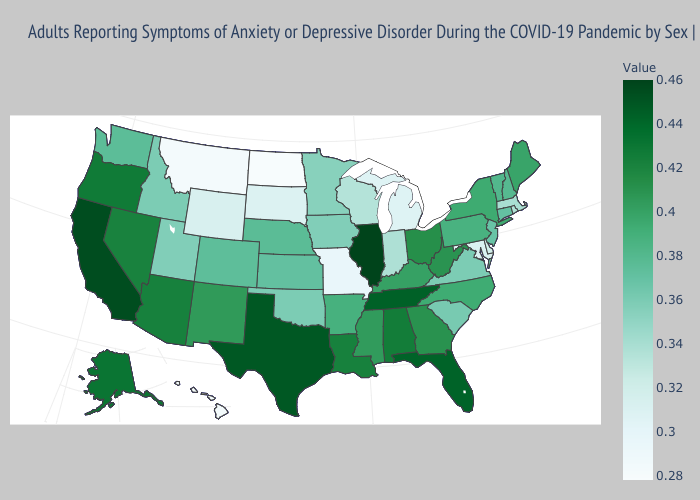Does Ohio have a higher value than Texas?
Concise answer only. No. Which states have the lowest value in the South?
Answer briefly. Maryland. Does Kentucky have a lower value than Alaska?
Be succinct. Yes. Among the states that border North Dakota , which have the lowest value?
Short answer required. Montana. 